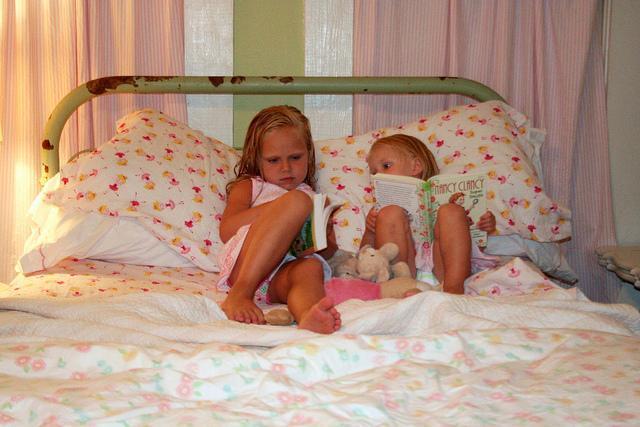How many people can you see?
Give a very brief answer. 2. 